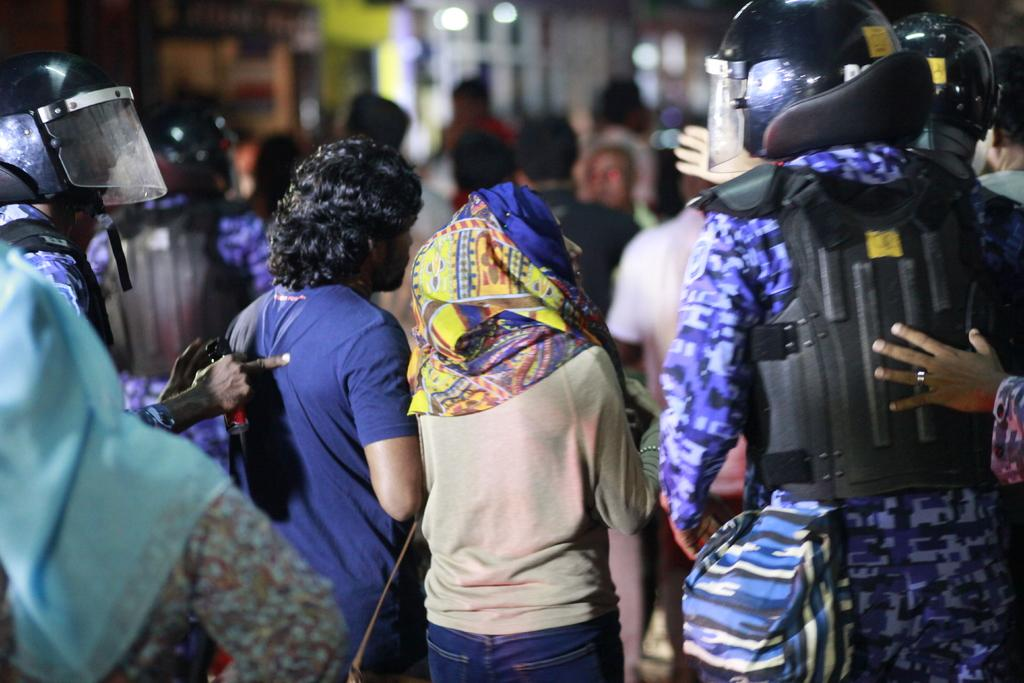Who or what is present in the image? There are people in the image. What are some of the people doing in the image? Some of the people are carrying bags. Can you describe the background of the image? The background of the image is blurred. What type of popcorn can be seen on the toes of the people in the image? There is no popcorn present in the image, and no mention of toes. 